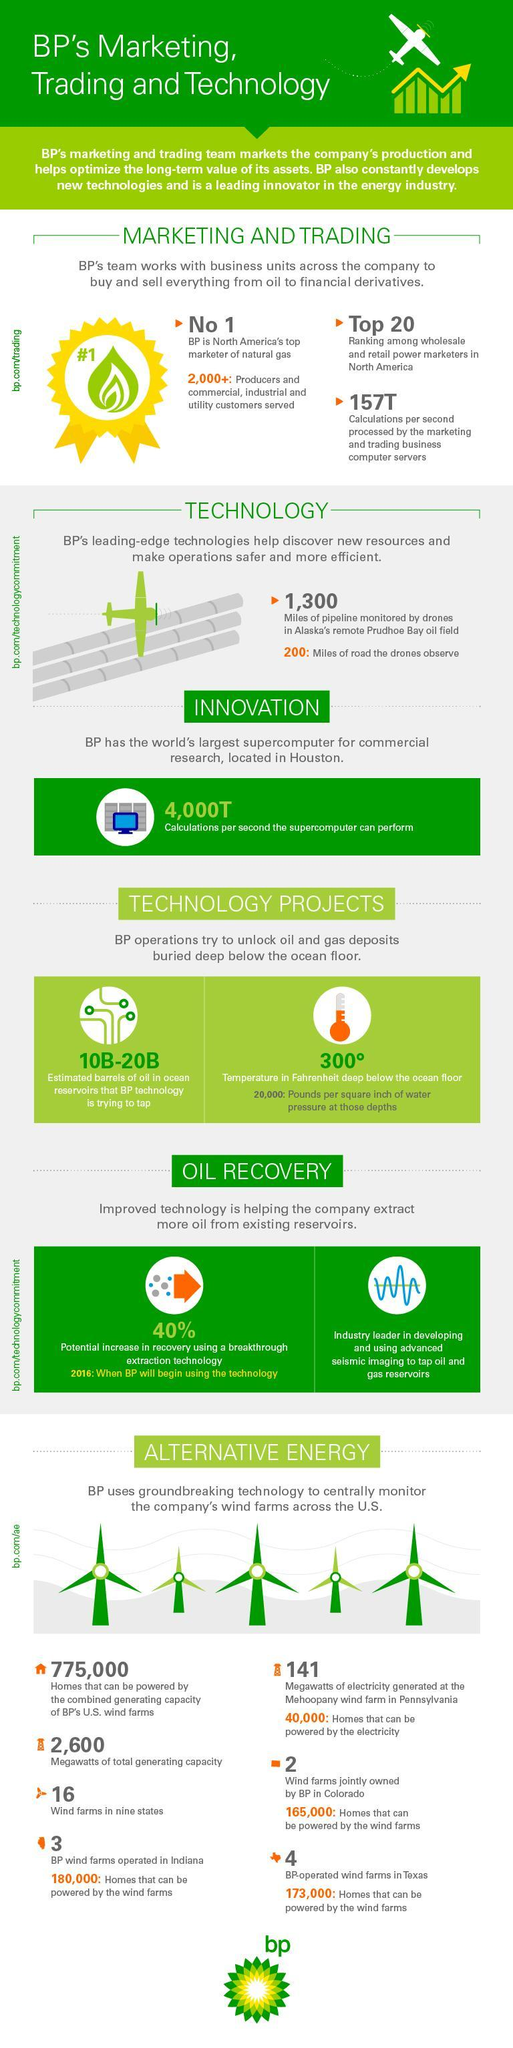What is the temperature in Fahrenheit deep below the ocean floor?
Answer the question with a short phrase. 300° What is the number of BP-operated wind farms in Texas? 4 How many homes can be powered by the combined generating capacity of BP's U.S. wind farms? 775,000 How many wind farms are jointly owned by BP in Colorado? 2 How many megawatts of electricity is generated at the Mehoopany wind farm in Pennsylvania? 141 What is the estimated barrels of oil in ocean reservoirs that BP technology is trying to tap? 10B-20B 